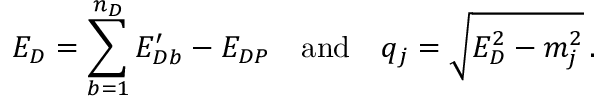<formula> <loc_0><loc_0><loc_500><loc_500>E _ { D } = \sum _ { b = 1 } ^ { n _ { D } } E _ { D b } ^ { \prime } - E _ { D P } \quad a n d \quad q _ { j } = \sqrt { E _ { D } ^ { 2 } - m _ { j } ^ { 2 } } \, .</formula> 